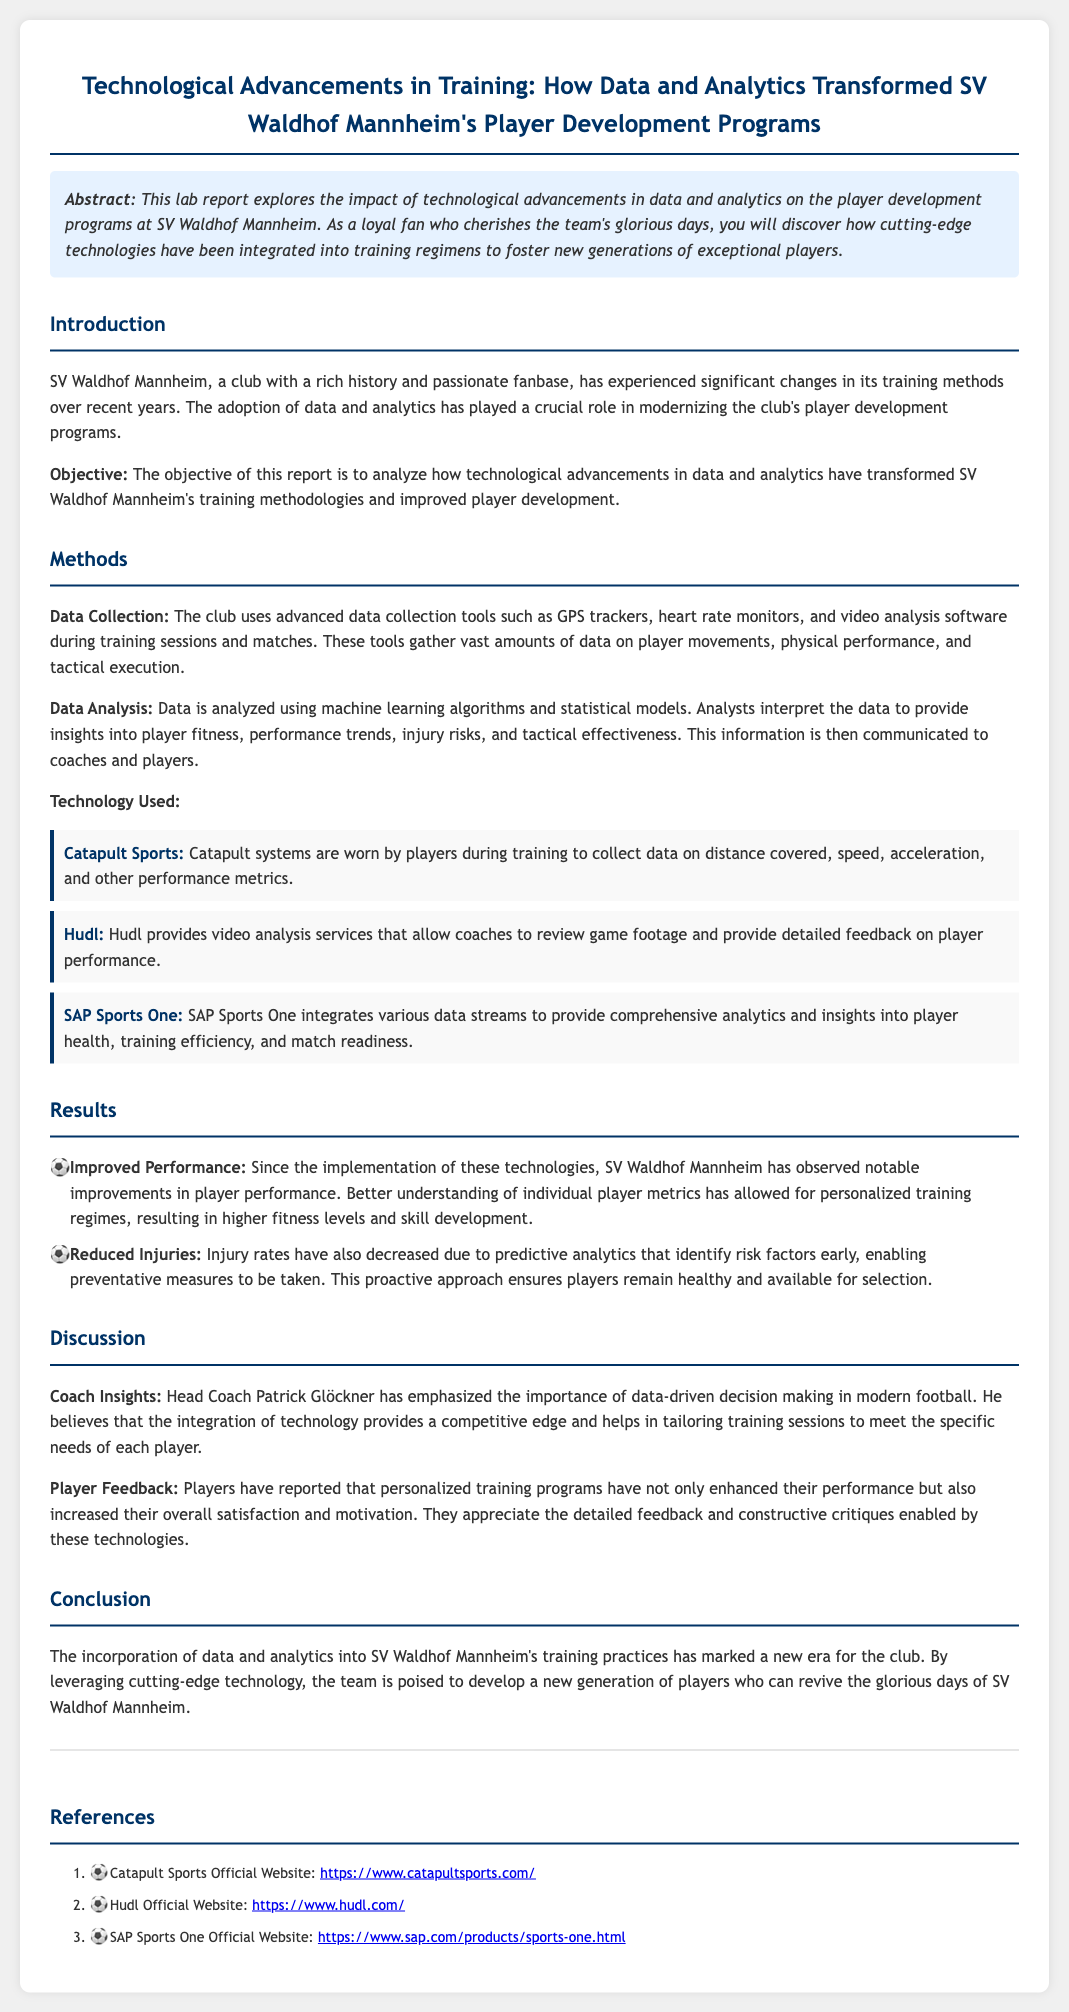What is the title of the lab report? The title of the lab report is stated at the beginning of the document, which is "Technological Advancements in Training: How Data and Analytics Transformed SV Waldhof Mannheim's Player Development Programs."
Answer: Technological Advancements in Training: How Data and Analytics Transformed SV Waldhof Mannheim's Player Development Programs What technological tool collects data on distance covered? The document mentions Catapult Sports as the tool used by players to collect data on various performance metrics, including distance covered.
Answer: Catapult Sports Who is the head coach mentioned in the report? The report highlights the insights provided by Head Coach Patrick Glöckner, who emphasizes the importance of data-driven decisions.
Answer: Patrick Glöckner What is one key benefit of using predictive analytics? The report explains that predictive analytics helps in identifying injury risk factors early, leading to preventative measures that keep players healthy.
Answer: Reduced Injuries What is the primary objective of the report? The objective is explicitly stated in the document as analyzing how technological advancements have transformed player development at SV Waldhof Mannheim.
Answer: Analyze how technological advancements have transformed player development What kind of feedback do players appreciate from the technologies? The report describes that players have expressed their appreciation for detailed feedback and constructive critiques enabled by the technologies used in training.
Answer: Detailed feedback and constructive critiques What is the background color of the abstract section? The document specifies that the abstract section has a background color of light blue represented by the code "#e6f2ff."
Answer: Light blue How has player performance improved according to the results? The results indicate that better understanding of individual player metrics has led to higher fitness levels and skill development, improving overall performance.
Answer: Notable improvements in player performance 